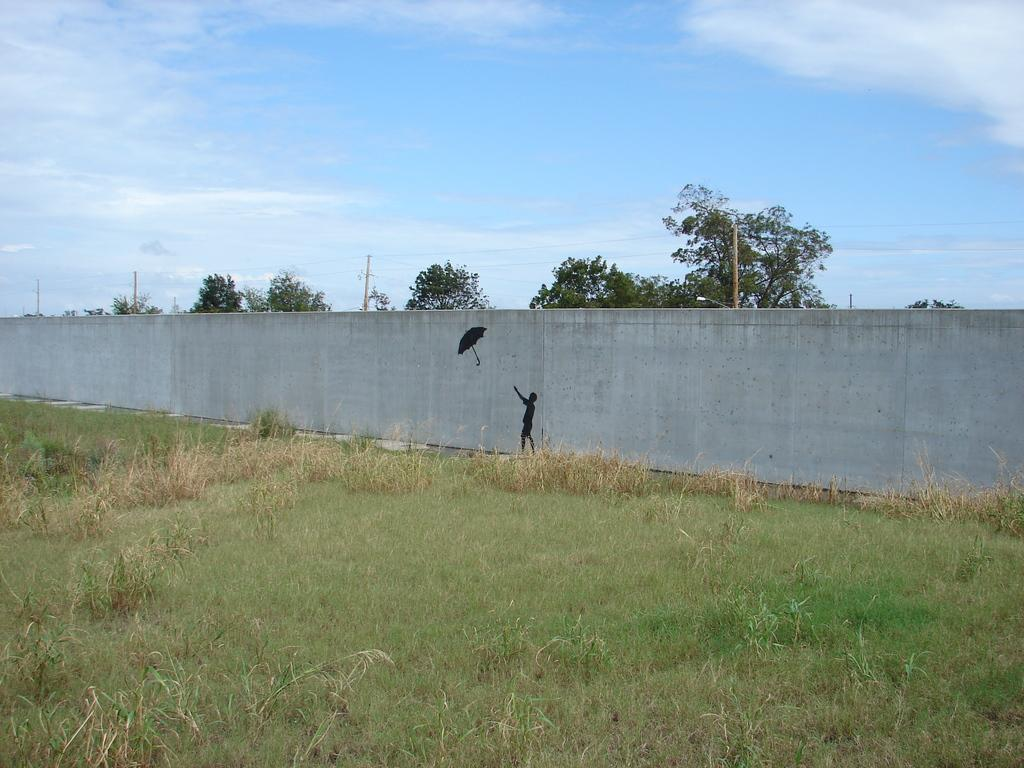What type of living organisms can be seen in the image? Plants and grass are visible in the image. Can you describe the person in the image? The person is holding an umbrella. What is in the background of the image? There is a wall, trees, electric poles, and the sky visible in the background of the image. What is the condition of the sky in the image? Clouds are present in the sky. What type of servant can be seen in the image? There is no servant present in the image. What type of paper is the person reading in the image? There is no paper present in the image; the person is holding an umbrella. 